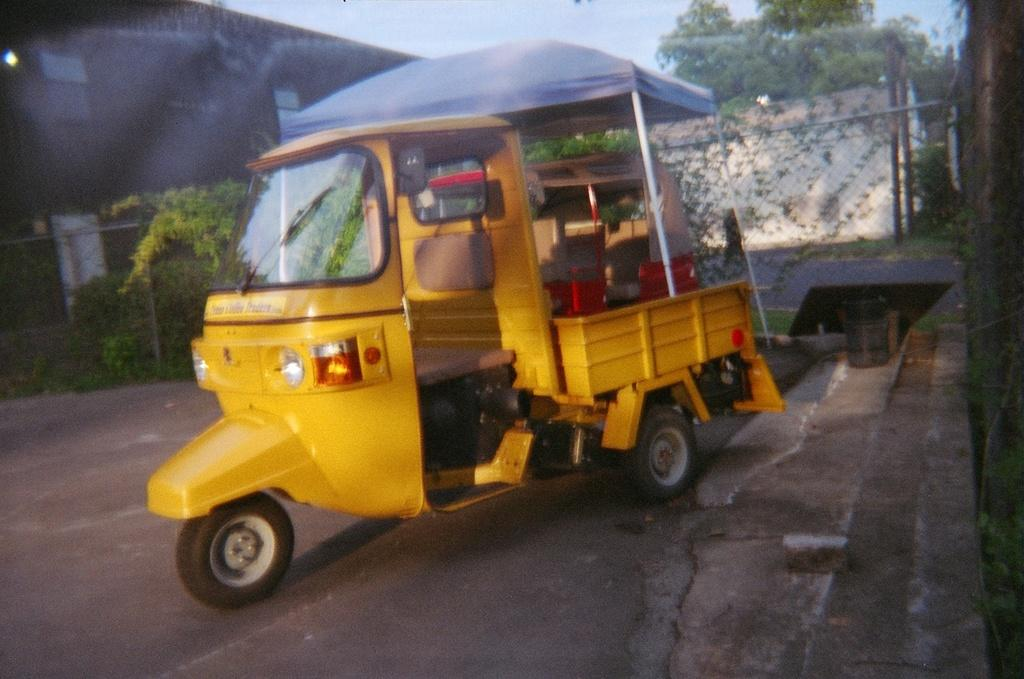What is the main subject in the center of the image? There is an auto in the center of the image. Where is the auto located? The auto is on the road. What can be seen in the background of the image? There are buildings, trees, and a mesh visible in the background of the image. What type of board is the maid using to clean the auto's windows in the image? There is no maid or board present in the image. 